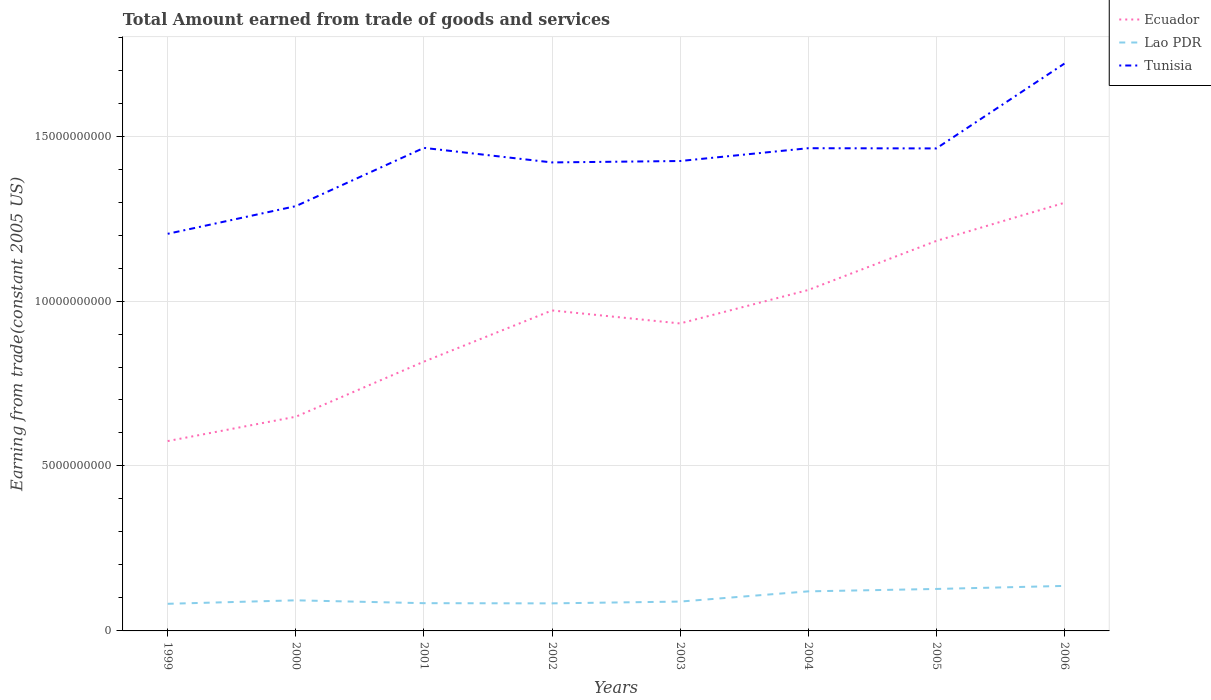Across all years, what is the maximum total amount earned by trading goods and services in Tunisia?
Provide a succinct answer. 1.20e+1. What is the total total amount earned by trading goods and services in Tunisia in the graph?
Provide a succinct answer. -2.21e+09. What is the difference between the highest and the second highest total amount earned by trading goods and services in Lao PDR?
Ensure brevity in your answer.  5.42e+08. How many lines are there?
Your answer should be compact. 3. What is the difference between two consecutive major ticks on the Y-axis?
Provide a short and direct response. 5.00e+09. Does the graph contain grids?
Your answer should be very brief. Yes. How many legend labels are there?
Your answer should be compact. 3. What is the title of the graph?
Your response must be concise. Total Amount earned from trade of goods and services. What is the label or title of the Y-axis?
Your answer should be compact. Earning from trade(constant 2005 US). What is the Earning from trade(constant 2005 US) in Ecuador in 1999?
Offer a very short reply. 5.75e+09. What is the Earning from trade(constant 2005 US) of Lao PDR in 1999?
Offer a very short reply. 8.22e+08. What is the Earning from trade(constant 2005 US) in Tunisia in 1999?
Your answer should be compact. 1.20e+1. What is the Earning from trade(constant 2005 US) of Ecuador in 2000?
Keep it short and to the point. 6.49e+09. What is the Earning from trade(constant 2005 US) of Lao PDR in 2000?
Provide a short and direct response. 9.28e+08. What is the Earning from trade(constant 2005 US) of Tunisia in 2000?
Keep it short and to the point. 1.29e+1. What is the Earning from trade(constant 2005 US) of Ecuador in 2001?
Your answer should be compact. 8.16e+09. What is the Earning from trade(constant 2005 US) of Lao PDR in 2001?
Keep it short and to the point. 8.41e+08. What is the Earning from trade(constant 2005 US) of Tunisia in 2001?
Provide a short and direct response. 1.46e+1. What is the Earning from trade(constant 2005 US) in Ecuador in 2002?
Offer a terse response. 9.71e+09. What is the Earning from trade(constant 2005 US) of Lao PDR in 2002?
Your response must be concise. 8.35e+08. What is the Earning from trade(constant 2005 US) of Tunisia in 2002?
Provide a succinct answer. 1.42e+1. What is the Earning from trade(constant 2005 US) in Ecuador in 2003?
Offer a terse response. 9.32e+09. What is the Earning from trade(constant 2005 US) of Lao PDR in 2003?
Offer a very short reply. 8.90e+08. What is the Earning from trade(constant 2005 US) of Tunisia in 2003?
Your response must be concise. 1.42e+1. What is the Earning from trade(constant 2005 US) of Ecuador in 2004?
Offer a terse response. 1.03e+1. What is the Earning from trade(constant 2005 US) in Lao PDR in 2004?
Make the answer very short. 1.20e+09. What is the Earning from trade(constant 2005 US) in Tunisia in 2004?
Provide a succinct answer. 1.46e+1. What is the Earning from trade(constant 2005 US) in Ecuador in 2005?
Your answer should be compact. 1.18e+1. What is the Earning from trade(constant 2005 US) of Lao PDR in 2005?
Provide a short and direct response. 1.27e+09. What is the Earning from trade(constant 2005 US) of Tunisia in 2005?
Give a very brief answer. 1.46e+1. What is the Earning from trade(constant 2005 US) of Ecuador in 2006?
Ensure brevity in your answer.  1.30e+1. What is the Earning from trade(constant 2005 US) in Lao PDR in 2006?
Your answer should be compact. 1.36e+09. What is the Earning from trade(constant 2005 US) in Tunisia in 2006?
Offer a very short reply. 1.72e+1. Across all years, what is the maximum Earning from trade(constant 2005 US) in Ecuador?
Give a very brief answer. 1.30e+1. Across all years, what is the maximum Earning from trade(constant 2005 US) of Lao PDR?
Provide a succinct answer. 1.36e+09. Across all years, what is the maximum Earning from trade(constant 2005 US) in Tunisia?
Provide a short and direct response. 1.72e+1. Across all years, what is the minimum Earning from trade(constant 2005 US) in Ecuador?
Offer a very short reply. 5.75e+09. Across all years, what is the minimum Earning from trade(constant 2005 US) in Lao PDR?
Your answer should be very brief. 8.22e+08. Across all years, what is the minimum Earning from trade(constant 2005 US) of Tunisia?
Your response must be concise. 1.20e+1. What is the total Earning from trade(constant 2005 US) of Ecuador in the graph?
Ensure brevity in your answer.  7.46e+1. What is the total Earning from trade(constant 2005 US) of Lao PDR in the graph?
Keep it short and to the point. 8.15e+09. What is the total Earning from trade(constant 2005 US) in Tunisia in the graph?
Make the answer very short. 1.14e+11. What is the difference between the Earning from trade(constant 2005 US) of Ecuador in 1999 and that in 2000?
Ensure brevity in your answer.  -7.38e+08. What is the difference between the Earning from trade(constant 2005 US) of Lao PDR in 1999 and that in 2000?
Offer a terse response. -1.06e+08. What is the difference between the Earning from trade(constant 2005 US) in Tunisia in 1999 and that in 2000?
Provide a short and direct response. -8.38e+08. What is the difference between the Earning from trade(constant 2005 US) in Ecuador in 1999 and that in 2001?
Offer a very short reply. -2.41e+09. What is the difference between the Earning from trade(constant 2005 US) of Lao PDR in 1999 and that in 2001?
Make the answer very short. -1.90e+07. What is the difference between the Earning from trade(constant 2005 US) of Tunisia in 1999 and that in 2001?
Your answer should be compact. -2.60e+09. What is the difference between the Earning from trade(constant 2005 US) of Ecuador in 1999 and that in 2002?
Offer a terse response. -3.96e+09. What is the difference between the Earning from trade(constant 2005 US) of Lao PDR in 1999 and that in 2002?
Offer a very short reply. -1.32e+07. What is the difference between the Earning from trade(constant 2005 US) in Tunisia in 1999 and that in 2002?
Your answer should be very brief. -2.16e+09. What is the difference between the Earning from trade(constant 2005 US) of Ecuador in 1999 and that in 2003?
Your answer should be compact. -3.57e+09. What is the difference between the Earning from trade(constant 2005 US) of Lao PDR in 1999 and that in 2003?
Provide a succinct answer. -6.76e+07. What is the difference between the Earning from trade(constant 2005 US) in Tunisia in 1999 and that in 2003?
Keep it short and to the point. -2.21e+09. What is the difference between the Earning from trade(constant 2005 US) of Ecuador in 1999 and that in 2004?
Your answer should be compact. -4.58e+09. What is the difference between the Earning from trade(constant 2005 US) in Lao PDR in 1999 and that in 2004?
Offer a terse response. -3.77e+08. What is the difference between the Earning from trade(constant 2005 US) in Tunisia in 1999 and that in 2004?
Offer a terse response. -2.59e+09. What is the difference between the Earning from trade(constant 2005 US) in Ecuador in 1999 and that in 2005?
Offer a very short reply. -6.07e+09. What is the difference between the Earning from trade(constant 2005 US) in Lao PDR in 1999 and that in 2005?
Provide a short and direct response. -4.50e+08. What is the difference between the Earning from trade(constant 2005 US) of Tunisia in 1999 and that in 2005?
Ensure brevity in your answer.  -2.59e+09. What is the difference between the Earning from trade(constant 2005 US) of Ecuador in 1999 and that in 2006?
Give a very brief answer. -7.22e+09. What is the difference between the Earning from trade(constant 2005 US) of Lao PDR in 1999 and that in 2006?
Your answer should be compact. -5.42e+08. What is the difference between the Earning from trade(constant 2005 US) in Tunisia in 1999 and that in 2006?
Give a very brief answer. -5.16e+09. What is the difference between the Earning from trade(constant 2005 US) in Ecuador in 2000 and that in 2001?
Give a very brief answer. -1.67e+09. What is the difference between the Earning from trade(constant 2005 US) in Lao PDR in 2000 and that in 2001?
Your response must be concise. 8.67e+07. What is the difference between the Earning from trade(constant 2005 US) of Tunisia in 2000 and that in 2001?
Your answer should be compact. -1.77e+09. What is the difference between the Earning from trade(constant 2005 US) in Ecuador in 2000 and that in 2002?
Offer a very short reply. -3.22e+09. What is the difference between the Earning from trade(constant 2005 US) of Lao PDR in 2000 and that in 2002?
Ensure brevity in your answer.  9.25e+07. What is the difference between the Earning from trade(constant 2005 US) of Tunisia in 2000 and that in 2002?
Ensure brevity in your answer.  -1.33e+09. What is the difference between the Earning from trade(constant 2005 US) in Ecuador in 2000 and that in 2003?
Make the answer very short. -2.83e+09. What is the difference between the Earning from trade(constant 2005 US) of Lao PDR in 2000 and that in 2003?
Make the answer very short. 3.82e+07. What is the difference between the Earning from trade(constant 2005 US) of Tunisia in 2000 and that in 2003?
Your response must be concise. -1.37e+09. What is the difference between the Earning from trade(constant 2005 US) in Ecuador in 2000 and that in 2004?
Provide a succinct answer. -3.84e+09. What is the difference between the Earning from trade(constant 2005 US) in Lao PDR in 2000 and that in 2004?
Give a very brief answer. -2.71e+08. What is the difference between the Earning from trade(constant 2005 US) in Tunisia in 2000 and that in 2004?
Make the answer very short. -1.76e+09. What is the difference between the Earning from trade(constant 2005 US) of Ecuador in 2000 and that in 2005?
Keep it short and to the point. -5.33e+09. What is the difference between the Earning from trade(constant 2005 US) in Lao PDR in 2000 and that in 2005?
Your answer should be compact. -3.44e+08. What is the difference between the Earning from trade(constant 2005 US) in Tunisia in 2000 and that in 2005?
Offer a terse response. -1.75e+09. What is the difference between the Earning from trade(constant 2005 US) of Ecuador in 2000 and that in 2006?
Make the answer very short. -6.48e+09. What is the difference between the Earning from trade(constant 2005 US) in Lao PDR in 2000 and that in 2006?
Give a very brief answer. -4.37e+08. What is the difference between the Earning from trade(constant 2005 US) of Tunisia in 2000 and that in 2006?
Offer a very short reply. -4.32e+09. What is the difference between the Earning from trade(constant 2005 US) in Ecuador in 2001 and that in 2002?
Ensure brevity in your answer.  -1.55e+09. What is the difference between the Earning from trade(constant 2005 US) in Lao PDR in 2001 and that in 2002?
Provide a succinct answer. 5.79e+06. What is the difference between the Earning from trade(constant 2005 US) in Tunisia in 2001 and that in 2002?
Ensure brevity in your answer.  4.41e+08. What is the difference between the Earning from trade(constant 2005 US) of Ecuador in 2001 and that in 2003?
Your answer should be very brief. -1.16e+09. What is the difference between the Earning from trade(constant 2005 US) in Lao PDR in 2001 and that in 2003?
Keep it short and to the point. -4.86e+07. What is the difference between the Earning from trade(constant 2005 US) in Tunisia in 2001 and that in 2003?
Offer a very short reply. 3.98e+08. What is the difference between the Earning from trade(constant 2005 US) of Ecuador in 2001 and that in 2004?
Offer a very short reply. -2.17e+09. What is the difference between the Earning from trade(constant 2005 US) of Lao PDR in 2001 and that in 2004?
Ensure brevity in your answer.  -3.58e+08. What is the difference between the Earning from trade(constant 2005 US) in Tunisia in 2001 and that in 2004?
Offer a very short reply. 1.00e+07. What is the difference between the Earning from trade(constant 2005 US) in Ecuador in 2001 and that in 2005?
Your answer should be compact. -3.66e+09. What is the difference between the Earning from trade(constant 2005 US) of Lao PDR in 2001 and that in 2005?
Keep it short and to the point. -4.31e+08. What is the difference between the Earning from trade(constant 2005 US) of Tunisia in 2001 and that in 2005?
Provide a succinct answer. 1.64e+07. What is the difference between the Earning from trade(constant 2005 US) in Ecuador in 2001 and that in 2006?
Your answer should be very brief. -4.81e+09. What is the difference between the Earning from trade(constant 2005 US) in Lao PDR in 2001 and that in 2006?
Provide a short and direct response. -5.23e+08. What is the difference between the Earning from trade(constant 2005 US) of Tunisia in 2001 and that in 2006?
Your answer should be compact. -2.56e+09. What is the difference between the Earning from trade(constant 2005 US) in Ecuador in 2002 and that in 2003?
Make the answer very short. 3.94e+08. What is the difference between the Earning from trade(constant 2005 US) in Lao PDR in 2002 and that in 2003?
Your answer should be very brief. -5.43e+07. What is the difference between the Earning from trade(constant 2005 US) of Tunisia in 2002 and that in 2003?
Offer a terse response. -4.30e+07. What is the difference between the Earning from trade(constant 2005 US) of Ecuador in 2002 and that in 2004?
Provide a succinct answer. -6.19e+08. What is the difference between the Earning from trade(constant 2005 US) in Lao PDR in 2002 and that in 2004?
Make the answer very short. -3.64e+08. What is the difference between the Earning from trade(constant 2005 US) of Tunisia in 2002 and that in 2004?
Make the answer very short. -4.31e+08. What is the difference between the Earning from trade(constant 2005 US) of Ecuador in 2002 and that in 2005?
Offer a terse response. -2.11e+09. What is the difference between the Earning from trade(constant 2005 US) of Lao PDR in 2002 and that in 2005?
Provide a short and direct response. -4.37e+08. What is the difference between the Earning from trade(constant 2005 US) of Tunisia in 2002 and that in 2005?
Keep it short and to the point. -4.24e+08. What is the difference between the Earning from trade(constant 2005 US) of Ecuador in 2002 and that in 2006?
Give a very brief answer. -3.26e+09. What is the difference between the Earning from trade(constant 2005 US) in Lao PDR in 2002 and that in 2006?
Make the answer very short. -5.29e+08. What is the difference between the Earning from trade(constant 2005 US) of Tunisia in 2002 and that in 2006?
Offer a terse response. -3.00e+09. What is the difference between the Earning from trade(constant 2005 US) of Ecuador in 2003 and that in 2004?
Keep it short and to the point. -1.01e+09. What is the difference between the Earning from trade(constant 2005 US) in Lao PDR in 2003 and that in 2004?
Make the answer very short. -3.10e+08. What is the difference between the Earning from trade(constant 2005 US) of Tunisia in 2003 and that in 2004?
Your response must be concise. -3.88e+08. What is the difference between the Earning from trade(constant 2005 US) in Ecuador in 2003 and that in 2005?
Provide a succinct answer. -2.50e+09. What is the difference between the Earning from trade(constant 2005 US) in Lao PDR in 2003 and that in 2005?
Give a very brief answer. -3.82e+08. What is the difference between the Earning from trade(constant 2005 US) of Tunisia in 2003 and that in 2005?
Your response must be concise. -3.81e+08. What is the difference between the Earning from trade(constant 2005 US) of Ecuador in 2003 and that in 2006?
Offer a terse response. -3.66e+09. What is the difference between the Earning from trade(constant 2005 US) of Lao PDR in 2003 and that in 2006?
Provide a short and direct response. -4.75e+08. What is the difference between the Earning from trade(constant 2005 US) of Tunisia in 2003 and that in 2006?
Your answer should be compact. -2.95e+09. What is the difference between the Earning from trade(constant 2005 US) of Ecuador in 2004 and that in 2005?
Offer a very short reply. -1.49e+09. What is the difference between the Earning from trade(constant 2005 US) of Lao PDR in 2004 and that in 2005?
Give a very brief answer. -7.28e+07. What is the difference between the Earning from trade(constant 2005 US) of Tunisia in 2004 and that in 2005?
Your answer should be compact. 6.40e+06. What is the difference between the Earning from trade(constant 2005 US) in Ecuador in 2004 and that in 2006?
Offer a terse response. -2.64e+09. What is the difference between the Earning from trade(constant 2005 US) in Lao PDR in 2004 and that in 2006?
Give a very brief answer. -1.65e+08. What is the difference between the Earning from trade(constant 2005 US) of Tunisia in 2004 and that in 2006?
Offer a very short reply. -2.57e+09. What is the difference between the Earning from trade(constant 2005 US) of Ecuador in 2005 and that in 2006?
Your response must be concise. -1.16e+09. What is the difference between the Earning from trade(constant 2005 US) of Lao PDR in 2005 and that in 2006?
Provide a succinct answer. -9.25e+07. What is the difference between the Earning from trade(constant 2005 US) in Tunisia in 2005 and that in 2006?
Your answer should be compact. -2.57e+09. What is the difference between the Earning from trade(constant 2005 US) in Ecuador in 1999 and the Earning from trade(constant 2005 US) in Lao PDR in 2000?
Give a very brief answer. 4.83e+09. What is the difference between the Earning from trade(constant 2005 US) in Ecuador in 1999 and the Earning from trade(constant 2005 US) in Tunisia in 2000?
Make the answer very short. -7.12e+09. What is the difference between the Earning from trade(constant 2005 US) of Lao PDR in 1999 and the Earning from trade(constant 2005 US) of Tunisia in 2000?
Your answer should be compact. -1.21e+1. What is the difference between the Earning from trade(constant 2005 US) in Ecuador in 1999 and the Earning from trade(constant 2005 US) in Lao PDR in 2001?
Make the answer very short. 4.91e+09. What is the difference between the Earning from trade(constant 2005 US) in Ecuador in 1999 and the Earning from trade(constant 2005 US) in Tunisia in 2001?
Give a very brief answer. -8.89e+09. What is the difference between the Earning from trade(constant 2005 US) in Lao PDR in 1999 and the Earning from trade(constant 2005 US) in Tunisia in 2001?
Your answer should be very brief. -1.38e+1. What is the difference between the Earning from trade(constant 2005 US) in Ecuador in 1999 and the Earning from trade(constant 2005 US) in Lao PDR in 2002?
Your response must be concise. 4.92e+09. What is the difference between the Earning from trade(constant 2005 US) of Ecuador in 1999 and the Earning from trade(constant 2005 US) of Tunisia in 2002?
Your response must be concise. -8.45e+09. What is the difference between the Earning from trade(constant 2005 US) of Lao PDR in 1999 and the Earning from trade(constant 2005 US) of Tunisia in 2002?
Give a very brief answer. -1.34e+1. What is the difference between the Earning from trade(constant 2005 US) of Ecuador in 1999 and the Earning from trade(constant 2005 US) of Lao PDR in 2003?
Give a very brief answer. 4.87e+09. What is the difference between the Earning from trade(constant 2005 US) of Ecuador in 1999 and the Earning from trade(constant 2005 US) of Tunisia in 2003?
Your answer should be very brief. -8.49e+09. What is the difference between the Earning from trade(constant 2005 US) in Lao PDR in 1999 and the Earning from trade(constant 2005 US) in Tunisia in 2003?
Give a very brief answer. -1.34e+1. What is the difference between the Earning from trade(constant 2005 US) of Ecuador in 1999 and the Earning from trade(constant 2005 US) of Lao PDR in 2004?
Offer a very short reply. 4.56e+09. What is the difference between the Earning from trade(constant 2005 US) in Ecuador in 1999 and the Earning from trade(constant 2005 US) in Tunisia in 2004?
Provide a short and direct response. -8.88e+09. What is the difference between the Earning from trade(constant 2005 US) in Lao PDR in 1999 and the Earning from trade(constant 2005 US) in Tunisia in 2004?
Provide a succinct answer. -1.38e+1. What is the difference between the Earning from trade(constant 2005 US) in Ecuador in 1999 and the Earning from trade(constant 2005 US) in Lao PDR in 2005?
Provide a succinct answer. 4.48e+09. What is the difference between the Earning from trade(constant 2005 US) in Ecuador in 1999 and the Earning from trade(constant 2005 US) in Tunisia in 2005?
Keep it short and to the point. -8.87e+09. What is the difference between the Earning from trade(constant 2005 US) in Lao PDR in 1999 and the Earning from trade(constant 2005 US) in Tunisia in 2005?
Provide a short and direct response. -1.38e+1. What is the difference between the Earning from trade(constant 2005 US) of Ecuador in 1999 and the Earning from trade(constant 2005 US) of Lao PDR in 2006?
Make the answer very short. 4.39e+09. What is the difference between the Earning from trade(constant 2005 US) in Ecuador in 1999 and the Earning from trade(constant 2005 US) in Tunisia in 2006?
Your response must be concise. -1.14e+1. What is the difference between the Earning from trade(constant 2005 US) in Lao PDR in 1999 and the Earning from trade(constant 2005 US) in Tunisia in 2006?
Give a very brief answer. -1.64e+1. What is the difference between the Earning from trade(constant 2005 US) of Ecuador in 2000 and the Earning from trade(constant 2005 US) of Lao PDR in 2001?
Provide a succinct answer. 5.65e+09. What is the difference between the Earning from trade(constant 2005 US) of Ecuador in 2000 and the Earning from trade(constant 2005 US) of Tunisia in 2001?
Keep it short and to the point. -8.15e+09. What is the difference between the Earning from trade(constant 2005 US) in Lao PDR in 2000 and the Earning from trade(constant 2005 US) in Tunisia in 2001?
Provide a succinct answer. -1.37e+1. What is the difference between the Earning from trade(constant 2005 US) in Ecuador in 2000 and the Earning from trade(constant 2005 US) in Lao PDR in 2002?
Provide a short and direct response. 5.66e+09. What is the difference between the Earning from trade(constant 2005 US) of Ecuador in 2000 and the Earning from trade(constant 2005 US) of Tunisia in 2002?
Your answer should be compact. -7.71e+09. What is the difference between the Earning from trade(constant 2005 US) of Lao PDR in 2000 and the Earning from trade(constant 2005 US) of Tunisia in 2002?
Offer a terse response. -1.33e+1. What is the difference between the Earning from trade(constant 2005 US) of Ecuador in 2000 and the Earning from trade(constant 2005 US) of Lao PDR in 2003?
Provide a short and direct response. 5.60e+09. What is the difference between the Earning from trade(constant 2005 US) in Ecuador in 2000 and the Earning from trade(constant 2005 US) in Tunisia in 2003?
Provide a succinct answer. -7.75e+09. What is the difference between the Earning from trade(constant 2005 US) of Lao PDR in 2000 and the Earning from trade(constant 2005 US) of Tunisia in 2003?
Provide a succinct answer. -1.33e+1. What is the difference between the Earning from trade(constant 2005 US) in Ecuador in 2000 and the Earning from trade(constant 2005 US) in Lao PDR in 2004?
Your response must be concise. 5.29e+09. What is the difference between the Earning from trade(constant 2005 US) of Ecuador in 2000 and the Earning from trade(constant 2005 US) of Tunisia in 2004?
Your response must be concise. -8.14e+09. What is the difference between the Earning from trade(constant 2005 US) of Lao PDR in 2000 and the Earning from trade(constant 2005 US) of Tunisia in 2004?
Your response must be concise. -1.37e+1. What is the difference between the Earning from trade(constant 2005 US) of Ecuador in 2000 and the Earning from trade(constant 2005 US) of Lao PDR in 2005?
Your answer should be very brief. 5.22e+09. What is the difference between the Earning from trade(constant 2005 US) in Ecuador in 2000 and the Earning from trade(constant 2005 US) in Tunisia in 2005?
Ensure brevity in your answer.  -8.13e+09. What is the difference between the Earning from trade(constant 2005 US) of Lao PDR in 2000 and the Earning from trade(constant 2005 US) of Tunisia in 2005?
Give a very brief answer. -1.37e+1. What is the difference between the Earning from trade(constant 2005 US) in Ecuador in 2000 and the Earning from trade(constant 2005 US) in Lao PDR in 2006?
Provide a short and direct response. 5.13e+09. What is the difference between the Earning from trade(constant 2005 US) of Ecuador in 2000 and the Earning from trade(constant 2005 US) of Tunisia in 2006?
Provide a short and direct response. -1.07e+1. What is the difference between the Earning from trade(constant 2005 US) of Lao PDR in 2000 and the Earning from trade(constant 2005 US) of Tunisia in 2006?
Provide a succinct answer. -1.63e+1. What is the difference between the Earning from trade(constant 2005 US) of Ecuador in 2001 and the Earning from trade(constant 2005 US) of Lao PDR in 2002?
Offer a terse response. 7.33e+09. What is the difference between the Earning from trade(constant 2005 US) of Ecuador in 2001 and the Earning from trade(constant 2005 US) of Tunisia in 2002?
Keep it short and to the point. -6.04e+09. What is the difference between the Earning from trade(constant 2005 US) in Lao PDR in 2001 and the Earning from trade(constant 2005 US) in Tunisia in 2002?
Offer a terse response. -1.34e+1. What is the difference between the Earning from trade(constant 2005 US) in Ecuador in 2001 and the Earning from trade(constant 2005 US) in Lao PDR in 2003?
Give a very brief answer. 7.27e+09. What is the difference between the Earning from trade(constant 2005 US) in Ecuador in 2001 and the Earning from trade(constant 2005 US) in Tunisia in 2003?
Keep it short and to the point. -6.08e+09. What is the difference between the Earning from trade(constant 2005 US) of Lao PDR in 2001 and the Earning from trade(constant 2005 US) of Tunisia in 2003?
Ensure brevity in your answer.  -1.34e+1. What is the difference between the Earning from trade(constant 2005 US) of Ecuador in 2001 and the Earning from trade(constant 2005 US) of Lao PDR in 2004?
Ensure brevity in your answer.  6.96e+09. What is the difference between the Earning from trade(constant 2005 US) of Ecuador in 2001 and the Earning from trade(constant 2005 US) of Tunisia in 2004?
Make the answer very short. -6.47e+09. What is the difference between the Earning from trade(constant 2005 US) of Lao PDR in 2001 and the Earning from trade(constant 2005 US) of Tunisia in 2004?
Keep it short and to the point. -1.38e+1. What is the difference between the Earning from trade(constant 2005 US) in Ecuador in 2001 and the Earning from trade(constant 2005 US) in Lao PDR in 2005?
Keep it short and to the point. 6.89e+09. What is the difference between the Earning from trade(constant 2005 US) of Ecuador in 2001 and the Earning from trade(constant 2005 US) of Tunisia in 2005?
Ensure brevity in your answer.  -6.46e+09. What is the difference between the Earning from trade(constant 2005 US) of Lao PDR in 2001 and the Earning from trade(constant 2005 US) of Tunisia in 2005?
Provide a succinct answer. -1.38e+1. What is the difference between the Earning from trade(constant 2005 US) of Ecuador in 2001 and the Earning from trade(constant 2005 US) of Lao PDR in 2006?
Offer a very short reply. 6.80e+09. What is the difference between the Earning from trade(constant 2005 US) in Ecuador in 2001 and the Earning from trade(constant 2005 US) in Tunisia in 2006?
Offer a terse response. -9.03e+09. What is the difference between the Earning from trade(constant 2005 US) in Lao PDR in 2001 and the Earning from trade(constant 2005 US) in Tunisia in 2006?
Make the answer very short. -1.64e+1. What is the difference between the Earning from trade(constant 2005 US) in Ecuador in 2002 and the Earning from trade(constant 2005 US) in Lao PDR in 2003?
Your response must be concise. 8.83e+09. What is the difference between the Earning from trade(constant 2005 US) in Ecuador in 2002 and the Earning from trade(constant 2005 US) in Tunisia in 2003?
Give a very brief answer. -4.53e+09. What is the difference between the Earning from trade(constant 2005 US) of Lao PDR in 2002 and the Earning from trade(constant 2005 US) of Tunisia in 2003?
Offer a very short reply. -1.34e+1. What is the difference between the Earning from trade(constant 2005 US) of Ecuador in 2002 and the Earning from trade(constant 2005 US) of Lao PDR in 2004?
Provide a short and direct response. 8.52e+09. What is the difference between the Earning from trade(constant 2005 US) in Ecuador in 2002 and the Earning from trade(constant 2005 US) in Tunisia in 2004?
Your answer should be very brief. -4.92e+09. What is the difference between the Earning from trade(constant 2005 US) of Lao PDR in 2002 and the Earning from trade(constant 2005 US) of Tunisia in 2004?
Your answer should be compact. -1.38e+1. What is the difference between the Earning from trade(constant 2005 US) in Ecuador in 2002 and the Earning from trade(constant 2005 US) in Lao PDR in 2005?
Give a very brief answer. 8.44e+09. What is the difference between the Earning from trade(constant 2005 US) of Ecuador in 2002 and the Earning from trade(constant 2005 US) of Tunisia in 2005?
Keep it short and to the point. -4.91e+09. What is the difference between the Earning from trade(constant 2005 US) in Lao PDR in 2002 and the Earning from trade(constant 2005 US) in Tunisia in 2005?
Your answer should be compact. -1.38e+1. What is the difference between the Earning from trade(constant 2005 US) of Ecuador in 2002 and the Earning from trade(constant 2005 US) of Lao PDR in 2006?
Ensure brevity in your answer.  8.35e+09. What is the difference between the Earning from trade(constant 2005 US) in Ecuador in 2002 and the Earning from trade(constant 2005 US) in Tunisia in 2006?
Ensure brevity in your answer.  -7.48e+09. What is the difference between the Earning from trade(constant 2005 US) of Lao PDR in 2002 and the Earning from trade(constant 2005 US) of Tunisia in 2006?
Provide a short and direct response. -1.64e+1. What is the difference between the Earning from trade(constant 2005 US) of Ecuador in 2003 and the Earning from trade(constant 2005 US) of Lao PDR in 2004?
Make the answer very short. 8.12e+09. What is the difference between the Earning from trade(constant 2005 US) in Ecuador in 2003 and the Earning from trade(constant 2005 US) in Tunisia in 2004?
Offer a very short reply. -5.31e+09. What is the difference between the Earning from trade(constant 2005 US) of Lao PDR in 2003 and the Earning from trade(constant 2005 US) of Tunisia in 2004?
Offer a very short reply. -1.37e+1. What is the difference between the Earning from trade(constant 2005 US) in Ecuador in 2003 and the Earning from trade(constant 2005 US) in Lao PDR in 2005?
Your answer should be compact. 8.05e+09. What is the difference between the Earning from trade(constant 2005 US) of Ecuador in 2003 and the Earning from trade(constant 2005 US) of Tunisia in 2005?
Offer a terse response. -5.31e+09. What is the difference between the Earning from trade(constant 2005 US) in Lao PDR in 2003 and the Earning from trade(constant 2005 US) in Tunisia in 2005?
Keep it short and to the point. -1.37e+1. What is the difference between the Earning from trade(constant 2005 US) of Ecuador in 2003 and the Earning from trade(constant 2005 US) of Lao PDR in 2006?
Give a very brief answer. 7.96e+09. What is the difference between the Earning from trade(constant 2005 US) in Ecuador in 2003 and the Earning from trade(constant 2005 US) in Tunisia in 2006?
Your response must be concise. -7.88e+09. What is the difference between the Earning from trade(constant 2005 US) in Lao PDR in 2003 and the Earning from trade(constant 2005 US) in Tunisia in 2006?
Ensure brevity in your answer.  -1.63e+1. What is the difference between the Earning from trade(constant 2005 US) in Ecuador in 2004 and the Earning from trade(constant 2005 US) in Lao PDR in 2005?
Ensure brevity in your answer.  9.06e+09. What is the difference between the Earning from trade(constant 2005 US) in Ecuador in 2004 and the Earning from trade(constant 2005 US) in Tunisia in 2005?
Make the answer very short. -4.29e+09. What is the difference between the Earning from trade(constant 2005 US) in Lao PDR in 2004 and the Earning from trade(constant 2005 US) in Tunisia in 2005?
Provide a short and direct response. -1.34e+1. What is the difference between the Earning from trade(constant 2005 US) in Ecuador in 2004 and the Earning from trade(constant 2005 US) in Lao PDR in 2006?
Offer a very short reply. 8.97e+09. What is the difference between the Earning from trade(constant 2005 US) of Ecuador in 2004 and the Earning from trade(constant 2005 US) of Tunisia in 2006?
Your answer should be very brief. -6.86e+09. What is the difference between the Earning from trade(constant 2005 US) in Lao PDR in 2004 and the Earning from trade(constant 2005 US) in Tunisia in 2006?
Keep it short and to the point. -1.60e+1. What is the difference between the Earning from trade(constant 2005 US) in Ecuador in 2005 and the Earning from trade(constant 2005 US) in Lao PDR in 2006?
Offer a very short reply. 1.05e+1. What is the difference between the Earning from trade(constant 2005 US) of Ecuador in 2005 and the Earning from trade(constant 2005 US) of Tunisia in 2006?
Provide a short and direct response. -5.38e+09. What is the difference between the Earning from trade(constant 2005 US) in Lao PDR in 2005 and the Earning from trade(constant 2005 US) in Tunisia in 2006?
Keep it short and to the point. -1.59e+1. What is the average Earning from trade(constant 2005 US) in Ecuador per year?
Give a very brief answer. 9.32e+09. What is the average Earning from trade(constant 2005 US) in Lao PDR per year?
Your response must be concise. 1.02e+09. What is the average Earning from trade(constant 2005 US) of Tunisia per year?
Provide a succinct answer. 1.43e+1. In the year 1999, what is the difference between the Earning from trade(constant 2005 US) in Ecuador and Earning from trade(constant 2005 US) in Lao PDR?
Provide a succinct answer. 4.93e+09. In the year 1999, what is the difference between the Earning from trade(constant 2005 US) in Ecuador and Earning from trade(constant 2005 US) in Tunisia?
Keep it short and to the point. -6.28e+09. In the year 1999, what is the difference between the Earning from trade(constant 2005 US) of Lao PDR and Earning from trade(constant 2005 US) of Tunisia?
Provide a succinct answer. -1.12e+1. In the year 2000, what is the difference between the Earning from trade(constant 2005 US) in Ecuador and Earning from trade(constant 2005 US) in Lao PDR?
Ensure brevity in your answer.  5.56e+09. In the year 2000, what is the difference between the Earning from trade(constant 2005 US) of Ecuador and Earning from trade(constant 2005 US) of Tunisia?
Ensure brevity in your answer.  -6.38e+09. In the year 2000, what is the difference between the Earning from trade(constant 2005 US) of Lao PDR and Earning from trade(constant 2005 US) of Tunisia?
Your answer should be very brief. -1.19e+1. In the year 2001, what is the difference between the Earning from trade(constant 2005 US) of Ecuador and Earning from trade(constant 2005 US) of Lao PDR?
Provide a short and direct response. 7.32e+09. In the year 2001, what is the difference between the Earning from trade(constant 2005 US) in Ecuador and Earning from trade(constant 2005 US) in Tunisia?
Your answer should be very brief. -6.48e+09. In the year 2001, what is the difference between the Earning from trade(constant 2005 US) of Lao PDR and Earning from trade(constant 2005 US) of Tunisia?
Keep it short and to the point. -1.38e+1. In the year 2002, what is the difference between the Earning from trade(constant 2005 US) in Ecuador and Earning from trade(constant 2005 US) in Lao PDR?
Keep it short and to the point. 8.88e+09. In the year 2002, what is the difference between the Earning from trade(constant 2005 US) in Ecuador and Earning from trade(constant 2005 US) in Tunisia?
Provide a short and direct response. -4.49e+09. In the year 2002, what is the difference between the Earning from trade(constant 2005 US) in Lao PDR and Earning from trade(constant 2005 US) in Tunisia?
Keep it short and to the point. -1.34e+1. In the year 2003, what is the difference between the Earning from trade(constant 2005 US) in Ecuador and Earning from trade(constant 2005 US) in Lao PDR?
Provide a short and direct response. 8.43e+09. In the year 2003, what is the difference between the Earning from trade(constant 2005 US) in Ecuador and Earning from trade(constant 2005 US) in Tunisia?
Provide a short and direct response. -4.92e+09. In the year 2003, what is the difference between the Earning from trade(constant 2005 US) of Lao PDR and Earning from trade(constant 2005 US) of Tunisia?
Offer a terse response. -1.34e+1. In the year 2004, what is the difference between the Earning from trade(constant 2005 US) of Ecuador and Earning from trade(constant 2005 US) of Lao PDR?
Your answer should be compact. 9.14e+09. In the year 2004, what is the difference between the Earning from trade(constant 2005 US) of Ecuador and Earning from trade(constant 2005 US) of Tunisia?
Your response must be concise. -4.30e+09. In the year 2004, what is the difference between the Earning from trade(constant 2005 US) of Lao PDR and Earning from trade(constant 2005 US) of Tunisia?
Your response must be concise. -1.34e+1. In the year 2005, what is the difference between the Earning from trade(constant 2005 US) of Ecuador and Earning from trade(constant 2005 US) of Lao PDR?
Ensure brevity in your answer.  1.05e+1. In the year 2005, what is the difference between the Earning from trade(constant 2005 US) of Ecuador and Earning from trade(constant 2005 US) of Tunisia?
Your response must be concise. -2.80e+09. In the year 2005, what is the difference between the Earning from trade(constant 2005 US) in Lao PDR and Earning from trade(constant 2005 US) in Tunisia?
Provide a succinct answer. -1.34e+1. In the year 2006, what is the difference between the Earning from trade(constant 2005 US) in Ecuador and Earning from trade(constant 2005 US) in Lao PDR?
Offer a terse response. 1.16e+1. In the year 2006, what is the difference between the Earning from trade(constant 2005 US) in Ecuador and Earning from trade(constant 2005 US) in Tunisia?
Offer a terse response. -4.22e+09. In the year 2006, what is the difference between the Earning from trade(constant 2005 US) in Lao PDR and Earning from trade(constant 2005 US) in Tunisia?
Your answer should be very brief. -1.58e+1. What is the ratio of the Earning from trade(constant 2005 US) in Ecuador in 1999 to that in 2000?
Your response must be concise. 0.89. What is the ratio of the Earning from trade(constant 2005 US) in Lao PDR in 1999 to that in 2000?
Your response must be concise. 0.89. What is the ratio of the Earning from trade(constant 2005 US) of Tunisia in 1999 to that in 2000?
Keep it short and to the point. 0.93. What is the ratio of the Earning from trade(constant 2005 US) of Ecuador in 1999 to that in 2001?
Your answer should be compact. 0.7. What is the ratio of the Earning from trade(constant 2005 US) in Lao PDR in 1999 to that in 2001?
Offer a very short reply. 0.98. What is the ratio of the Earning from trade(constant 2005 US) in Tunisia in 1999 to that in 2001?
Your answer should be compact. 0.82. What is the ratio of the Earning from trade(constant 2005 US) in Ecuador in 1999 to that in 2002?
Offer a terse response. 0.59. What is the ratio of the Earning from trade(constant 2005 US) in Lao PDR in 1999 to that in 2002?
Make the answer very short. 0.98. What is the ratio of the Earning from trade(constant 2005 US) in Tunisia in 1999 to that in 2002?
Make the answer very short. 0.85. What is the ratio of the Earning from trade(constant 2005 US) in Ecuador in 1999 to that in 2003?
Your answer should be compact. 0.62. What is the ratio of the Earning from trade(constant 2005 US) of Lao PDR in 1999 to that in 2003?
Your answer should be very brief. 0.92. What is the ratio of the Earning from trade(constant 2005 US) in Tunisia in 1999 to that in 2003?
Provide a succinct answer. 0.85. What is the ratio of the Earning from trade(constant 2005 US) in Ecuador in 1999 to that in 2004?
Offer a terse response. 0.56. What is the ratio of the Earning from trade(constant 2005 US) of Lao PDR in 1999 to that in 2004?
Provide a succinct answer. 0.69. What is the ratio of the Earning from trade(constant 2005 US) of Tunisia in 1999 to that in 2004?
Provide a short and direct response. 0.82. What is the ratio of the Earning from trade(constant 2005 US) in Ecuador in 1999 to that in 2005?
Provide a succinct answer. 0.49. What is the ratio of the Earning from trade(constant 2005 US) in Lao PDR in 1999 to that in 2005?
Your answer should be compact. 0.65. What is the ratio of the Earning from trade(constant 2005 US) in Tunisia in 1999 to that in 2005?
Offer a very short reply. 0.82. What is the ratio of the Earning from trade(constant 2005 US) of Ecuador in 1999 to that in 2006?
Your answer should be compact. 0.44. What is the ratio of the Earning from trade(constant 2005 US) of Lao PDR in 1999 to that in 2006?
Your answer should be compact. 0.6. What is the ratio of the Earning from trade(constant 2005 US) in Ecuador in 2000 to that in 2001?
Make the answer very short. 0.8. What is the ratio of the Earning from trade(constant 2005 US) in Lao PDR in 2000 to that in 2001?
Ensure brevity in your answer.  1.1. What is the ratio of the Earning from trade(constant 2005 US) of Tunisia in 2000 to that in 2001?
Ensure brevity in your answer.  0.88. What is the ratio of the Earning from trade(constant 2005 US) in Ecuador in 2000 to that in 2002?
Your answer should be very brief. 0.67. What is the ratio of the Earning from trade(constant 2005 US) of Lao PDR in 2000 to that in 2002?
Give a very brief answer. 1.11. What is the ratio of the Earning from trade(constant 2005 US) in Tunisia in 2000 to that in 2002?
Your response must be concise. 0.91. What is the ratio of the Earning from trade(constant 2005 US) in Ecuador in 2000 to that in 2003?
Your response must be concise. 0.7. What is the ratio of the Earning from trade(constant 2005 US) in Lao PDR in 2000 to that in 2003?
Offer a terse response. 1.04. What is the ratio of the Earning from trade(constant 2005 US) in Tunisia in 2000 to that in 2003?
Give a very brief answer. 0.9. What is the ratio of the Earning from trade(constant 2005 US) in Ecuador in 2000 to that in 2004?
Your response must be concise. 0.63. What is the ratio of the Earning from trade(constant 2005 US) of Lao PDR in 2000 to that in 2004?
Give a very brief answer. 0.77. What is the ratio of the Earning from trade(constant 2005 US) in Ecuador in 2000 to that in 2005?
Your response must be concise. 0.55. What is the ratio of the Earning from trade(constant 2005 US) in Lao PDR in 2000 to that in 2005?
Give a very brief answer. 0.73. What is the ratio of the Earning from trade(constant 2005 US) of Tunisia in 2000 to that in 2005?
Offer a terse response. 0.88. What is the ratio of the Earning from trade(constant 2005 US) of Ecuador in 2000 to that in 2006?
Your answer should be compact. 0.5. What is the ratio of the Earning from trade(constant 2005 US) of Lao PDR in 2000 to that in 2006?
Offer a terse response. 0.68. What is the ratio of the Earning from trade(constant 2005 US) of Tunisia in 2000 to that in 2006?
Your response must be concise. 0.75. What is the ratio of the Earning from trade(constant 2005 US) in Ecuador in 2001 to that in 2002?
Your answer should be very brief. 0.84. What is the ratio of the Earning from trade(constant 2005 US) in Tunisia in 2001 to that in 2002?
Your answer should be compact. 1.03. What is the ratio of the Earning from trade(constant 2005 US) in Ecuador in 2001 to that in 2003?
Keep it short and to the point. 0.88. What is the ratio of the Earning from trade(constant 2005 US) of Lao PDR in 2001 to that in 2003?
Your answer should be very brief. 0.95. What is the ratio of the Earning from trade(constant 2005 US) in Tunisia in 2001 to that in 2003?
Keep it short and to the point. 1.03. What is the ratio of the Earning from trade(constant 2005 US) of Ecuador in 2001 to that in 2004?
Ensure brevity in your answer.  0.79. What is the ratio of the Earning from trade(constant 2005 US) of Lao PDR in 2001 to that in 2004?
Ensure brevity in your answer.  0.7. What is the ratio of the Earning from trade(constant 2005 US) of Tunisia in 2001 to that in 2004?
Offer a very short reply. 1. What is the ratio of the Earning from trade(constant 2005 US) of Ecuador in 2001 to that in 2005?
Your answer should be very brief. 0.69. What is the ratio of the Earning from trade(constant 2005 US) in Lao PDR in 2001 to that in 2005?
Provide a succinct answer. 0.66. What is the ratio of the Earning from trade(constant 2005 US) in Ecuador in 2001 to that in 2006?
Offer a terse response. 0.63. What is the ratio of the Earning from trade(constant 2005 US) in Lao PDR in 2001 to that in 2006?
Provide a short and direct response. 0.62. What is the ratio of the Earning from trade(constant 2005 US) in Tunisia in 2001 to that in 2006?
Your response must be concise. 0.85. What is the ratio of the Earning from trade(constant 2005 US) in Ecuador in 2002 to that in 2003?
Make the answer very short. 1.04. What is the ratio of the Earning from trade(constant 2005 US) of Lao PDR in 2002 to that in 2003?
Keep it short and to the point. 0.94. What is the ratio of the Earning from trade(constant 2005 US) of Tunisia in 2002 to that in 2003?
Your response must be concise. 1. What is the ratio of the Earning from trade(constant 2005 US) in Ecuador in 2002 to that in 2004?
Offer a terse response. 0.94. What is the ratio of the Earning from trade(constant 2005 US) in Lao PDR in 2002 to that in 2004?
Your answer should be very brief. 0.7. What is the ratio of the Earning from trade(constant 2005 US) of Tunisia in 2002 to that in 2004?
Provide a succinct answer. 0.97. What is the ratio of the Earning from trade(constant 2005 US) of Ecuador in 2002 to that in 2005?
Provide a succinct answer. 0.82. What is the ratio of the Earning from trade(constant 2005 US) in Lao PDR in 2002 to that in 2005?
Your answer should be compact. 0.66. What is the ratio of the Earning from trade(constant 2005 US) in Ecuador in 2002 to that in 2006?
Keep it short and to the point. 0.75. What is the ratio of the Earning from trade(constant 2005 US) in Lao PDR in 2002 to that in 2006?
Give a very brief answer. 0.61. What is the ratio of the Earning from trade(constant 2005 US) of Tunisia in 2002 to that in 2006?
Your answer should be compact. 0.83. What is the ratio of the Earning from trade(constant 2005 US) of Ecuador in 2003 to that in 2004?
Offer a very short reply. 0.9. What is the ratio of the Earning from trade(constant 2005 US) in Lao PDR in 2003 to that in 2004?
Offer a very short reply. 0.74. What is the ratio of the Earning from trade(constant 2005 US) of Tunisia in 2003 to that in 2004?
Your answer should be very brief. 0.97. What is the ratio of the Earning from trade(constant 2005 US) of Ecuador in 2003 to that in 2005?
Offer a very short reply. 0.79. What is the ratio of the Earning from trade(constant 2005 US) of Lao PDR in 2003 to that in 2005?
Provide a short and direct response. 0.7. What is the ratio of the Earning from trade(constant 2005 US) in Tunisia in 2003 to that in 2005?
Your response must be concise. 0.97. What is the ratio of the Earning from trade(constant 2005 US) in Ecuador in 2003 to that in 2006?
Your answer should be compact. 0.72. What is the ratio of the Earning from trade(constant 2005 US) of Lao PDR in 2003 to that in 2006?
Your answer should be compact. 0.65. What is the ratio of the Earning from trade(constant 2005 US) in Tunisia in 2003 to that in 2006?
Your answer should be compact. 0.83. What is the ratio of the Earning from trade(constant 2005 US) in Ecuador in 2004 to that in 2005?
Give a very brief answer. 0.87. What is the ratio of the Earning from trade(constant 2005 US) of Lao PDR in 2004 to that in 2005?
Keep it short and to the point. 0.94. What is the ratio of the Earning from trade(constant 2005 US) of Tunisia in 2004 to that in 2005?
Give a very brief answer. 1. What is the ratio of the Earning from trade(constant 2005 US) of Ecuador in 2004 to that in 2006?
Keep it short and to the point. 0.8. What is the ratio of the Earning from trade(constant 2005 US) in Lao PDR in 2004 to that in 2006?
Keep it short and to the point. 0.88. What is the ratio of the Earning from trade(constant 2005 US) in Tunisia in 2004 to that in 2006?
Keep it short and to the point. 0.85. What is the ratio of the Earning from trade(constant 2005 US) of Ecuador in 2005 to that in 2006?
Make the answer very short. 0.91. What is the ratio of the Earning from trade(constant 2005 US) of Lao PDR in 2005 to that in 2006?
Make the answer very short. 0.93. What is the ratio of the Earning from trade(constant 2005 US) of Tunisia in 2005 to that in 2006?
Provide a succinct answer. 0.85. What is the difference between the highest and the second highest Earning from trade(constant 2005 US) of Ecuador?
Your response must be concise. 1.16e+09. What is the difference between the highest and the second highest Earning from trade(constant 2005 US) in Lao PDR?
Offer a very short reply. 9.25e+07. What is the difference between the highest and the second highest Earning from trade(constant 2005 US) of Tunisia?
Your response must be concise. 2.56e+09. What is the difference between the highest and the lowest Earning from trade(constant 2005 US) in Ecuador?
Provide a short and direct response. 7.22e+09. What is the difference between the highest and the lowest Earning from trade(constant 2005 US) of Lao PDR?
Make the answer very short. 5.42e+08. What is the difference between the highest and the lowest Earning from trade(constant 2005 US) in Tunisia?
Provide a succinct answer. 5.16e+09. 